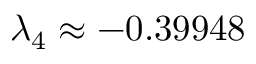Convert formula to latex. <formula><loc_0><loc_0><loc_500><loc_500>\lambda _ { 4 } \approx - 0 . 3 9 9 4 8</formula> 